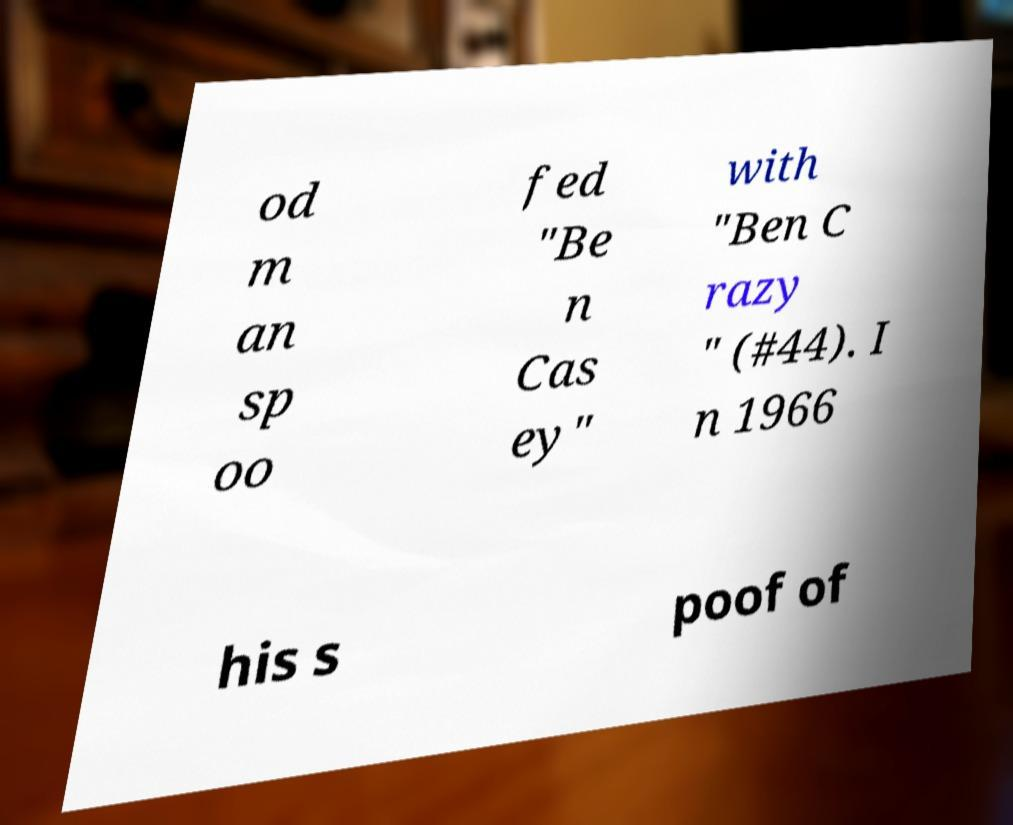Can you read and provide the text displayed in the image?This photo seems to have some interesting text. Can you extract and type it out for me? od m an sp oo fed "Be n Cas ey" with "Ben C razy " (#44). I n 1966 his s poof of 